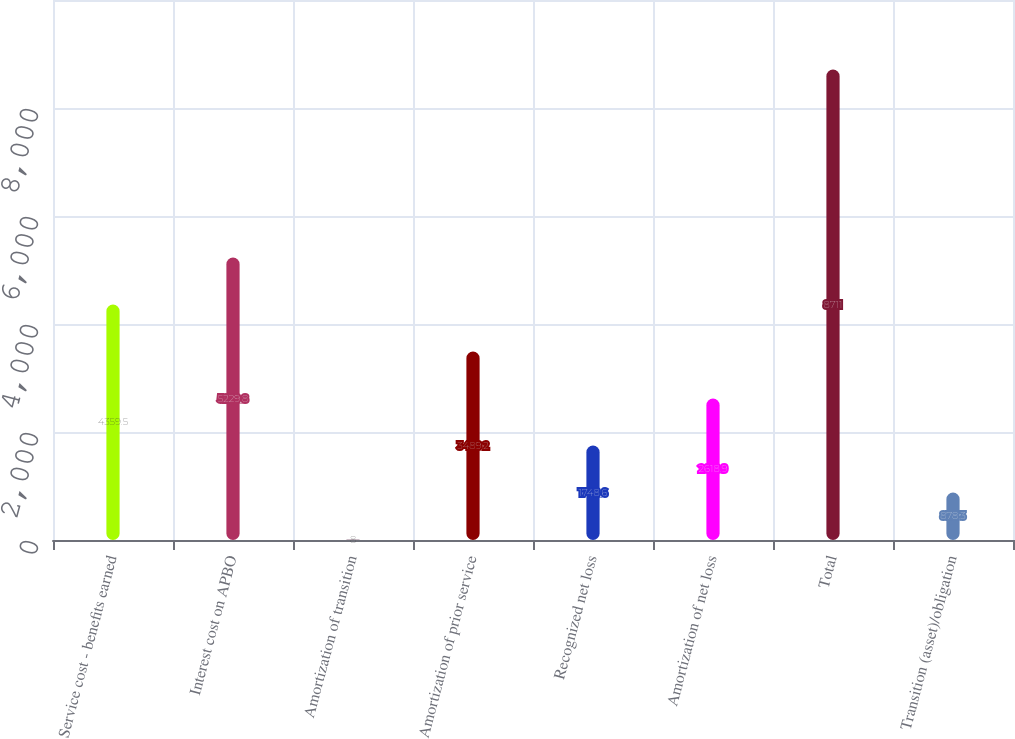<chart> <loc_0><loc_0><loc_500><loc_500><bar_chart><fcel>Service cost - benefits earned<fcel>Interest cost on APBO<fcel>Amortization of transition<fcel>Amortization of prior service<fcel>Recognized net loss<fcel>Amortization of net loss<fcel>Total<fcel>Transition (asset)/obligation<nl><fcel>4359.5<fcel>5229.8<fcel>8<fcel>3489.2<fcel>1748.6<fcel>2618.9<fcel>8711<fcel>878.3<nl></chart> 